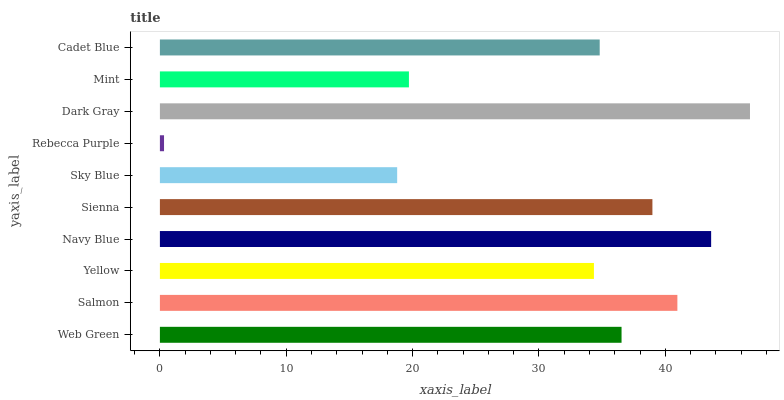Is Rebecca Purple the minimum?
Answer yes or no. Yes. Is Dark Gray the maximum?
Answer yes or no. Yes. Is Salmon the minimum?
Answer yes or no. No. Is Salmon the maximum?
Answer yes or no. No. Is Salmon greater than Web Green?
Answer yes or no. Yes. Is Web Green less than Salmon?
Answer yes or no. Yes. Is Web Green greater than Salmon?
Answer yes or no. No. Is Salmon less than Web Green?
Answer yes or no. No. Is Web Green the high median?
Answer yes or no. Yes. Is Cadet Blue the low median?
Answer yes or no. Yes. Is Rebecca Purple the high median?
Answer yes or no. No. Is Sienna the low median?
Answer yes or no. No. 